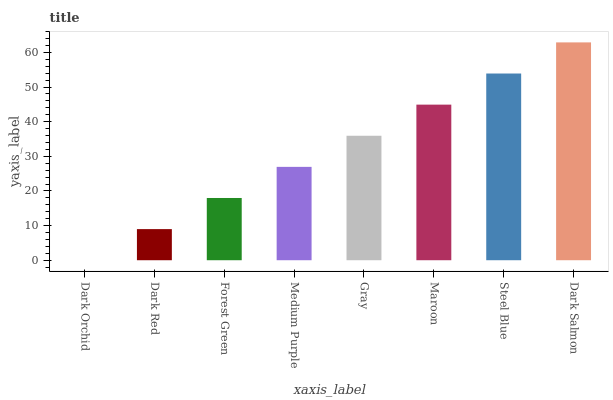Is Dark Orchid the minimum?
Answer yes or no. Yes. Is Dark Salmon the maximum?
Answer yes or no. Yes. Is Dark Red the minimum?
Answer yes or no. No. Is Dark Red the maximum?
Answer yes or no. No. Is Dark Red greater than Dark Orchid?
Answer yes or no. Yes. Is Dark Orchid less than Dark Red?
Answer yes or no. Yes. Is Dark Orchid greater than Dark Red?
Answer yes or no. No. Is Dark Red less than Dark Orchid?
Answer yes or no. No. Is Gray the high median?
Answer yes or no. Yes. Is Medium Purple the low median?
Answer yes or no. Yes. Is Dark Orchid the high median?
Answer yes or no. No. Is Dark Red the low median?
Answer yes or no. No. 